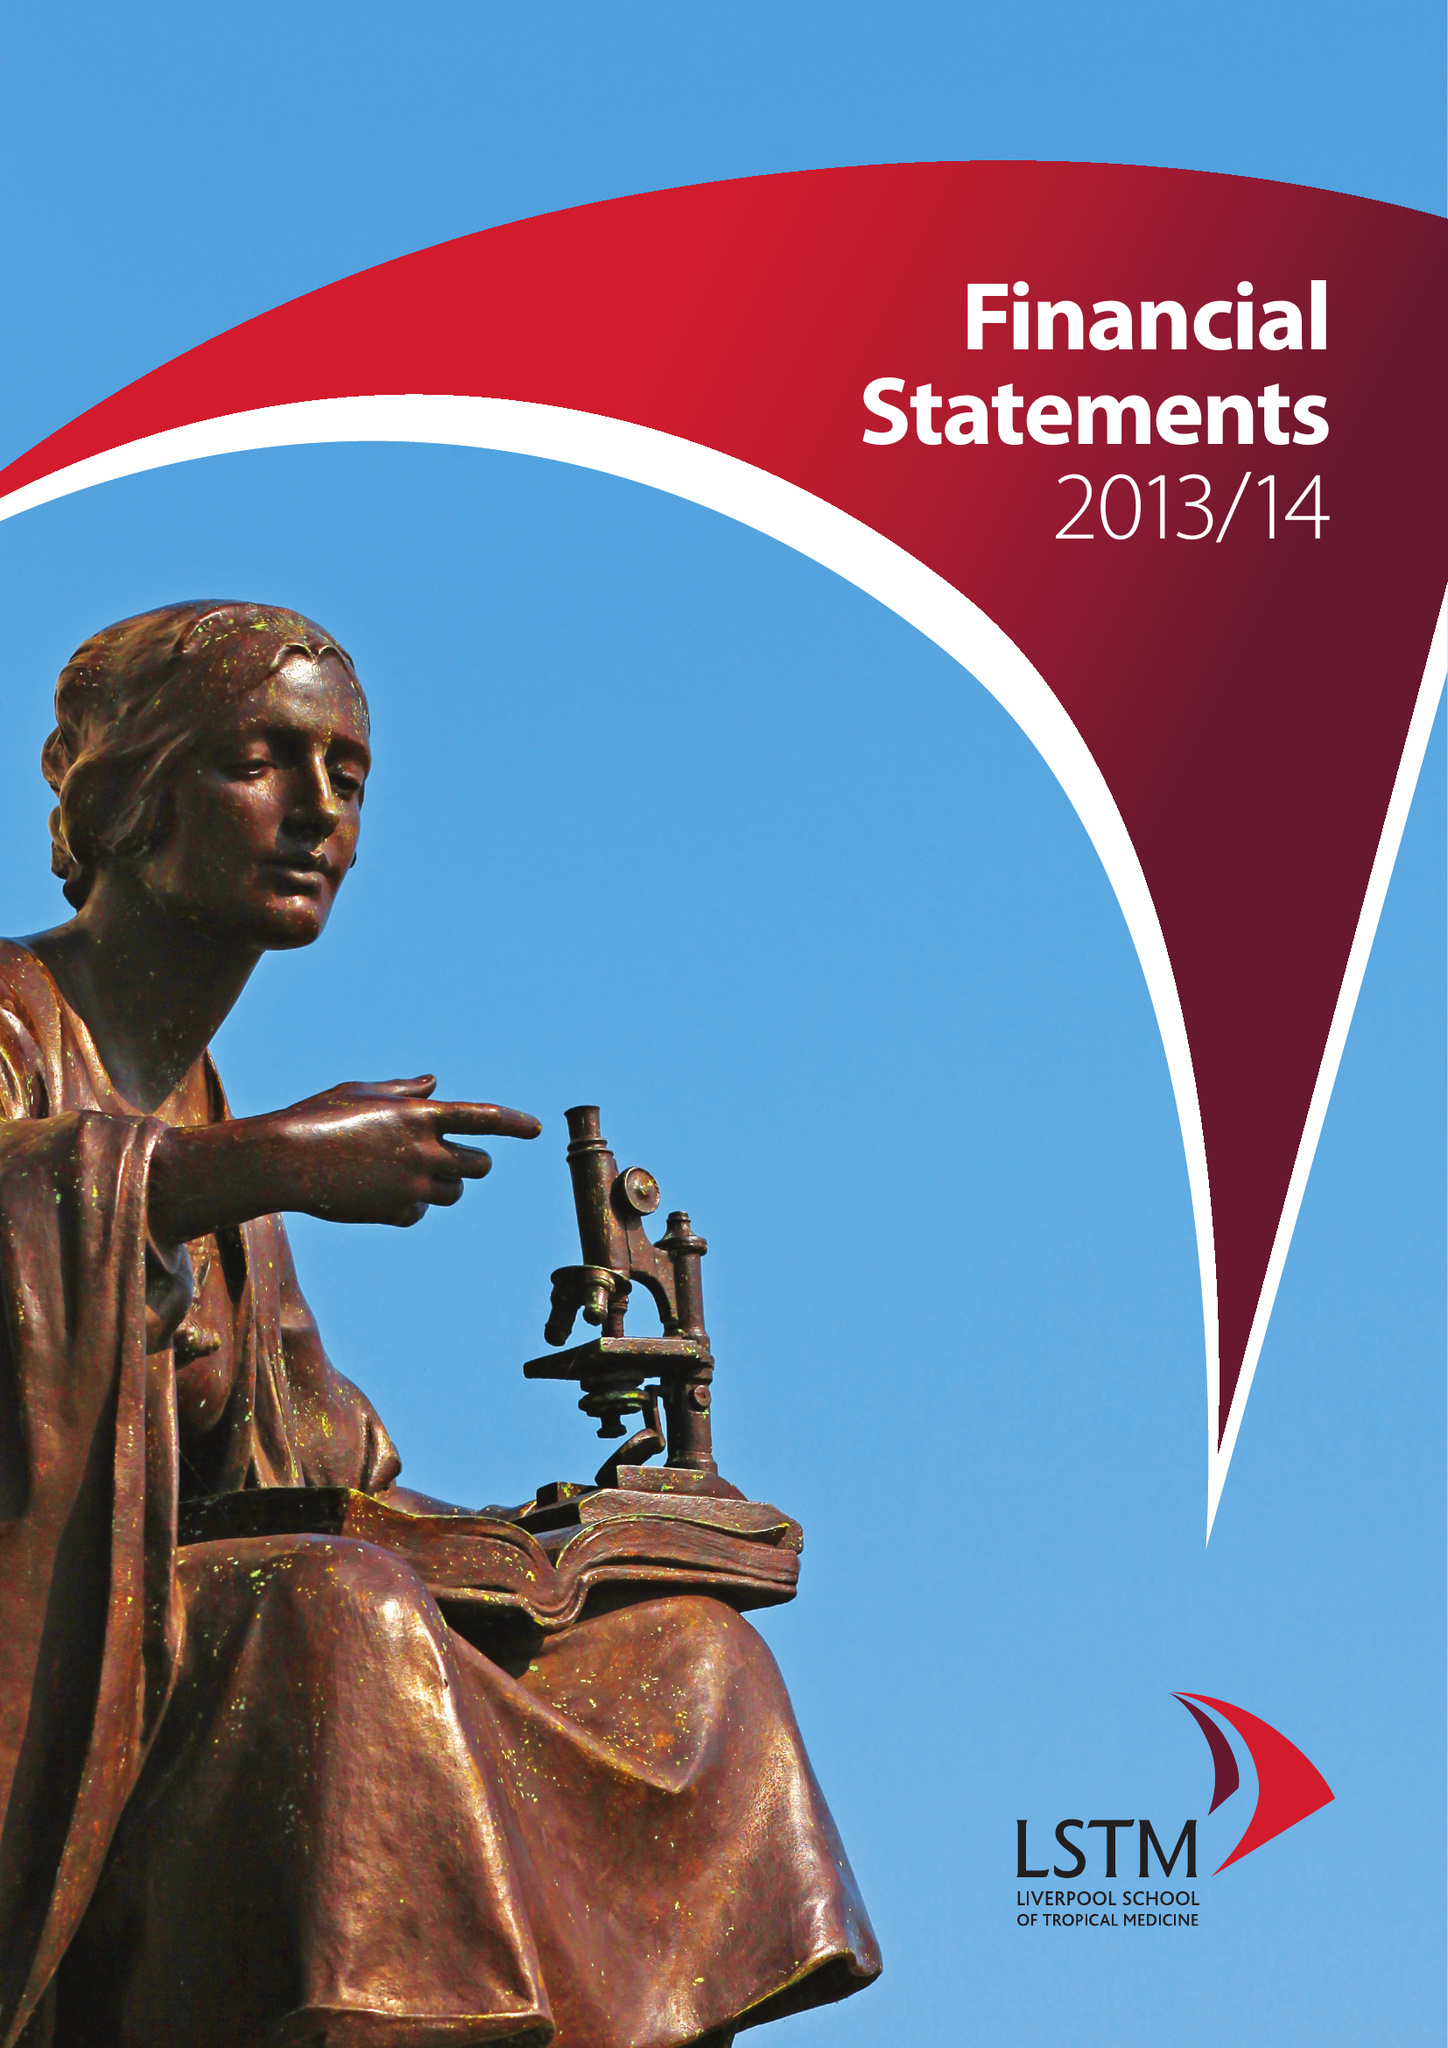What is the value for the address__postcode?
Answer the question using a single word or phrase. L3 5QA 